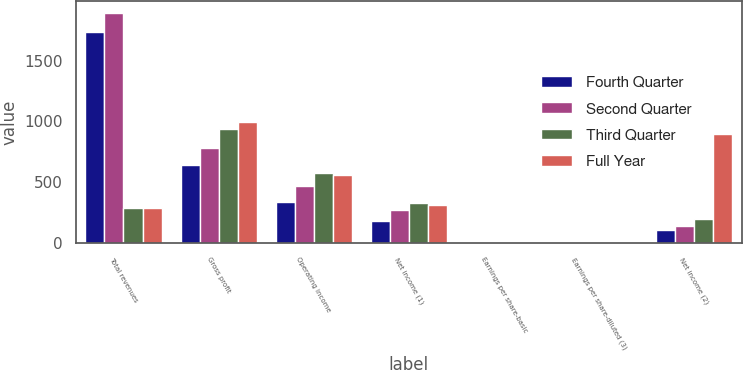Convert chart to OTSL. <chart><loc_0><loc_0><loc_500><loc_500><stacked_bar_chart><ecel><fcel>Total revenues<fcel>Gross profit<fcel>Operating income<fcel>Net income (1)<fcel>Earnings per share-basic<fcel>Earnings per share-diluted (3)<fcel>Net income (2)<nl><fcel>Fourth Quarter<fcel>1734<fcel>646<fcel>340<fcel>183<fcel>2.18<fcel>2.15<fcel>109<nl><fcel>Second Quarter<fcel>1891<fcel>782<fcel>470<fcel>270<fcel>3.22<fcel>3.2<fcel>141<nl><fcel>Third Quarter<fcel>290<fcel>938<fcel>578<fcel>333<fcel>4.05<fcel>4.01<fcel>199<nl><fcel>Full Year<fcel>290<fcel>998<fcel>563<fcel>310<fcel>3.84<fcel>3.8<fcel>897<nl></chart> 